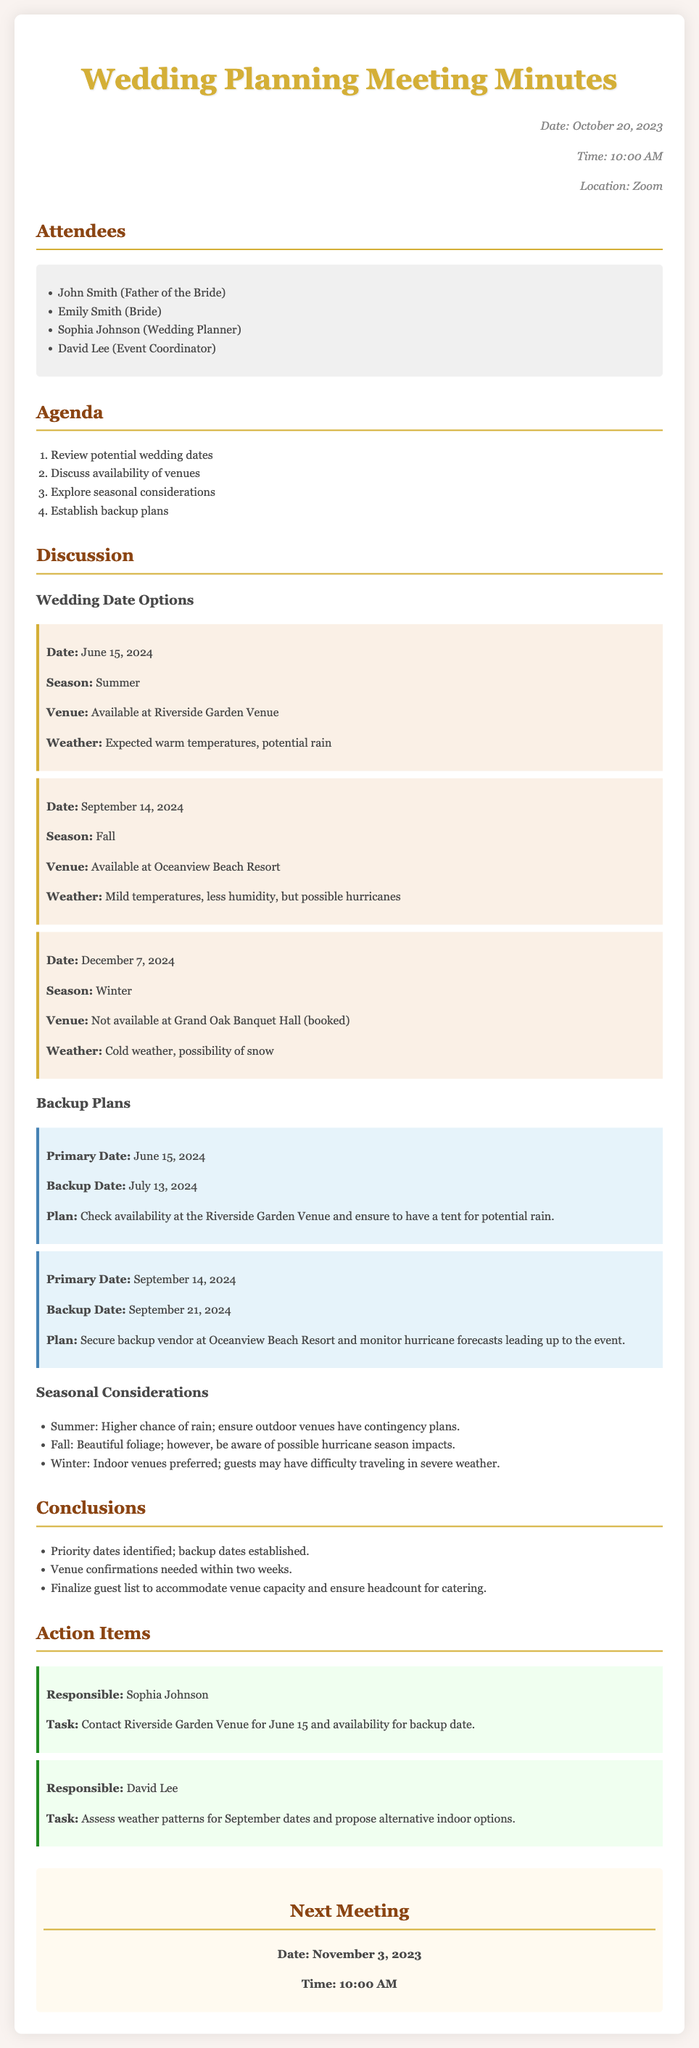What is the primary wedding date option discussed? The primary wedding date option discussed is specific to June 15, 2024, as mentioned in the section on wedding date options.
Answer: June 15, 2024 What venue is available for the primary date? The document specifies that the Riverside Garden Venue is available for the primary date of June 15, 2024.
Answer: Riverside Garden Venue What is the weather expectation for September 14, 2024? The document mentions that on September 14, 2024, the expected weather will have mild temperatures and less humidity, but also highlights the risk of possible hurricanes.
Answer: Mild temperatures, possible hurricanes What is the backup date for June 15, 2024? The backup plan section outlines that the backup date for the primary date of June 15, 2024, is July 13, 2024.
Answer: July 13, 2024 Who is responsible for contacting the Riverside Garden Venue? An action item indicates that Sophia Johnson is responsible for contacting the Riverside Garden Venue.
Answer: Sophia Johnson What is one seasonal consideration mentioned for winter? The document lists that in winter, indoor venues are preferred due to potential severe weather impacting guest travel.
Answer: Indoor venues preferred What are the attendees' names? The attendees' section lists names including John Smith, Emily Smith, Sophia Johnson, and David Lee.
Answer: John Smith, Emily Smith, Sophia Johnson, David Lee When is the next meeting scheduled? The next meeting is scheduled for November 3, 2023, as indicated in the meeting minutes.
Answer: November 3, 2023 